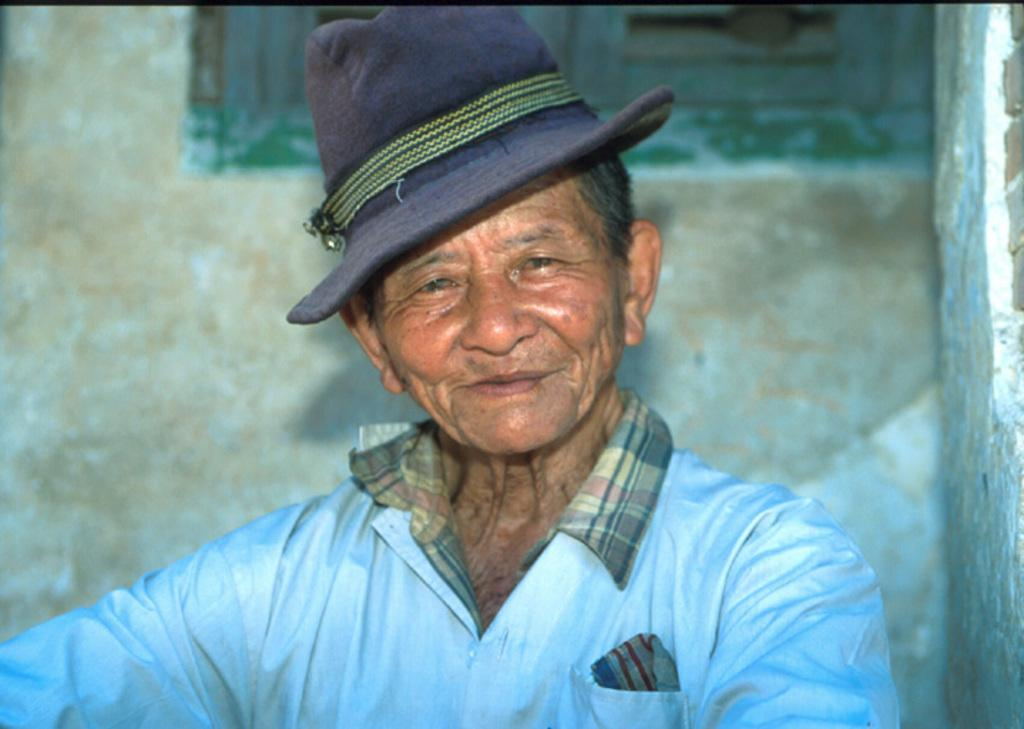Who or what is present in the image? There is a person in the image. What is the person wearing on their upper body? The person is wearing a blue jacket. What is the person wearing on their head? The person is wearing a blue hat. What can be seen in the background of the image? There is a wall and a window in the background of the image. What type of copper bead is hanging from the top of the window in the image? There is no copper bead or any bead present in the image. 